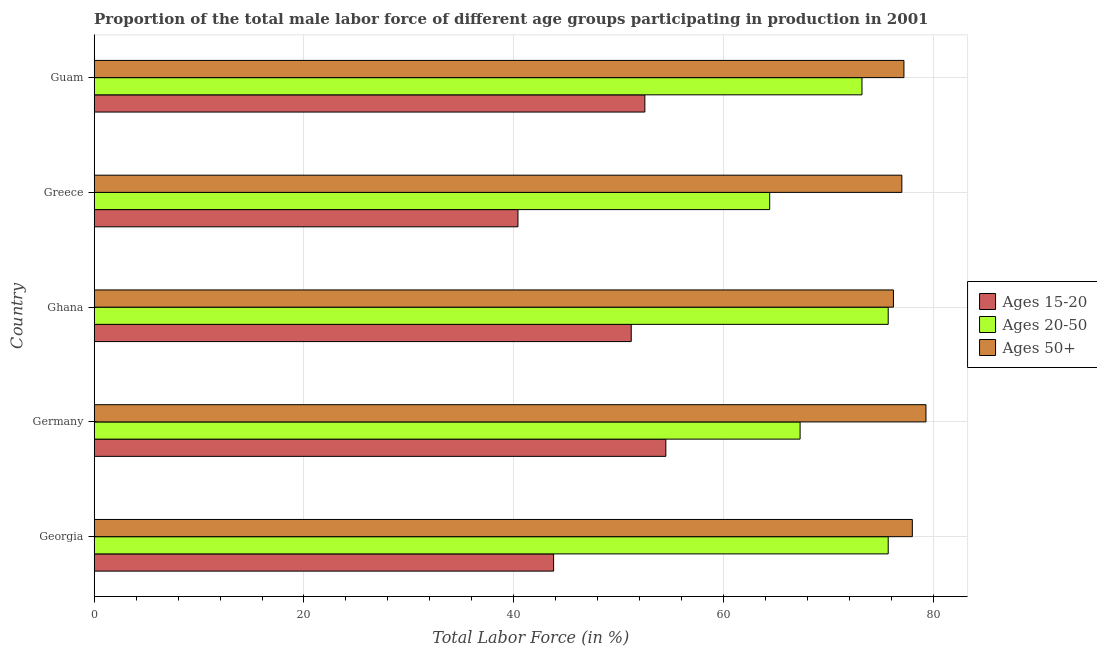How many groups of bars are there?
Ensure brevity in your answer.  5. Are the number of bars per tick equal to the number of legend labels?
Give a very brief answer. Yes. How many bars are there on the 2nd tick from the top?
Your response must be concise. 3. In how many cases, is the number of bars for a given country not equal to the number of legend labels?
Provide a succinct answer. 0. What is the percentage of male labor force above age 50 in Ghana?
Offer a very short reply. 76.2. Across all countries, what is the maximum percentage of male labor force within the age group 20-50?
Your answer should be very brief. 75.7. Across all countries, what is the minimum percentage of male labor force within the age group 15-20?
Offer a very short reply. 40.4. In which country was the percentage of male labor force within the age group 20-50 maximum?
Offer a terse response. Georgia. What is the total percentage of male labor force within the age group 20-50 in the graph?
Your answer should be very brief. 356.3. What is the difference between the percentage of male labor force within the age group 20-50 in Ghana and that in Guam?
Offer a very short reply. 2.5. What is the difference between the percentage of male labor force above age 50 in Ghana and the percentage of male labor force within the age group 20-50 in Greece?
Offer a very short reply. 11.8. What is the average percentage of male labor force within the age group 15-20 per country?
Your response must be concise. 48.48. What is the difference between the percentage of male labor force within the age group 15-20 and percentage of male labor force within the age group 20-50 in Ghana?
Give a very brief answer. -24.5. What is the ratio of the percentage of male labor force above age 50 in Ghana to that in Greece?
Your response must be concise. 0.99. Is the difference between the percentage of male labor force within the age group 20-50 in Germany and Guam greater than the difference between the percentage of male labor force within the age group 15-20 in Germany and Guam?
Give a very brief answer. No. What is the difference between the highest and the second highest percentage of male labor force within the age group 15-20?
Your answer should be compact. 2. What does the 3rd bar from the top in Ghana represents?
Your answer should be very brief. Ages 15-20. What does the 3rd bar from the bottom in Greece represents?
Offer a very short reply. Ages 50+. Is it the case that in every country, the sum of the percentage of male labor force within the age group 15-20 and percentage of male labor force within the age group 20-50 is greater than the percentage of male labor force above age 50?
Give a very brief answer. Yes. Are all the bars in the graph horizontal?
Your answer should be compact. Yes. What is the difference between two consecutive major ticks on the X-axis?
Ensure brevity in your answer.  20. Are the values on the major ticks of X-axis written in scientific E-notation?
Your answer should be very brief. No. Where does the legend appear in the graph?
Ensure brevity in your answer.  Center right. How many legend labels are there?
Your response must be concise. 3. How are the legend labels stacked?
Provide a succinct answer. Vertical. What is the title of the graph?
Give a very brief answer. Proportion of the total male labor force of different age groups participating in production in 2001. Does "Hydroelectric sources" appear as one of the legend labels in the graph?
Make the answer very short. No. What is the Total Labor Force (in %) in Ages 15-20 in Georgia?
Your answer should be very brief. 43.8. What is the Total Labor Force (in %) in Ages 20-50 in Georgia?
Your response must be concise. 75.7. What is the Total Labor Force (in %) of Ages 50+ in Georgia?
Your answer should be compact. 78. What is the Total Labor Force (in %) in Ages 15-20 in Germany?
Your answer should be compact. 54.5. What is the Total Labor Force (in %) in Ages 20-50 in Germany?
Provide a succinct answer. 67.3. What is the Total Labor Force (in %) in Ages 50+ in Germany?
Your answer should be compact. 79.3. What is the Total Labor Force (in %) of Ages 15-20 in Ghana?
Ensure brevity in your answer.  51.2. What is the Total Labor Force (in %) of Ages 20-50 in Ghana?
Offer a very short reply. 75.7. What is the Total Labor Force (in %) in Ages 50+ in Ghana?
Offer a terse response. 76.2. What is the Total Labor Force (in %) of Ages 15-20 in Greece?
Provide a short and direct response. 40.4. What is the Total Labor Force (in %) in Ages 20-50 in Greece?
Your answer should be very brief. 64.4. What is the Total Labor Force (in %) of Ages 50+ in Greece?
Make the answer very short. 77. What is the Total Labor Force (in %) of Ages 15-20 in Guam?
Offer a very short reply. 52.5. What is the Total Labor Force (in %) of Ages 20-50 in Guam?
Offer a terse response. 73.2. What is the Total Labor Force (in %) of Ages 50+ in Guam?
Make the answer very short. 77.2. Across all countries, what is the maximum Total Labor Force (in %) of Ages 15-20?
Provide a succinct answer. 54.5. Across all countries, what is the maximum Total Labor Force (in %) of Ages 20-50?
Ensure brevity in your answer.  75.7. Across all countries, what is the maximum Total Labor Force (in %) of Ages 50+?
Give a very brief answer. 79.3. Across all countries, what is the minimum Total Labor Force (in %) in Ages 15-20?
Provide a short and direct response. 40.4. Across all countries, what is the minimum Total Labor Force (in %) of Ages 20-50?
Ensure brevity in your answer.  64.4. Across all countries, what is the minimum Total Labor Force (in %) in Ages 50+?
Offer a terse response. 76.2. What is the total Total Labor Force (in %) in Ages 15-20 in the graph?
Your answer should be compact. 242.4. What is the total Total Labor Force (in %) in Ages 20-50 in the graph?
Your answer should be compact. 356.3. What is the total Total Labor Force (in %) in Ages 50+ in the graph?
Provide a short and direct response. 387.7. What is the difference between the Total Labor Force (in %) of Ages 20-50 in Georgia and that in Germany?
Provide a short and direct response. 8.4. What is the difference between the Total Labor Force (in %) of Ages 50+ in Georgia and that in Germany?
Your answer should be very brief. -1.3. What is the difference between the Total Labor Force (in %) of Ages 15-20 in Georgia and that in Ghana?
Offer a terse response. -7.4. What is the difference between the Total Labor Force (in %) in Ages 50+ in Georgia and that in Ghana?
Give a very brief answer. 1.8. What is the difference between the Total Labor Force (in %) of Ages 15-20 in Georgia and that in Greece?
Ensure brevity in your answer.  3.4. What is the difference between the Total Labor Force (in %) in Ages 20-50 in Georgia and that in Greece?
Provide a succinct answer. 11.3. What is the difference between the Total Labor Force (in %) in Ages 50+ in Georgia and that in Greece?
Keep it short and to the point. 1. What is the difference between the Total Labor Force (in %) in Ages 20-50 in Georgia and that in Guam?
Provide a short and direct response. 2.5. What is the difference between the Total Labor Force (in %) of Ages 20-50 in Germany and that in Ghana?
Your answer should be very brief. -8.4. What is the difference between the Total Labor Force (in %) of Ages 15-20 in Germany and that in Greece?
Your response must be concise. 14.1. What is the difference between the Total Labor Force (in %) of Ages 20-50 in Germany and that in Greece?
Your response must be concise. 2.9. What is the difference between the Total Labor Force (in %) in Ages 15-20 in Germany and that in Guam?
Provide a succinct answer. 2. What is the difference between the Total Labor Force (in %) of Ages 20-50 in Germany and that in Guam?
Keep it short and to the point. -5.9. What is the difference between the Total Labor Force (in %) in Ages 50+ in Germany and that in Guam?
Ensure brevity in your answer.  2.1. What is the difference between the Total Labor Force (in %) of Ages 20-50 in Ghana and that in Greece?
Provide a succinct answer. 11.3. What is the difference between the Total Labor Force (in %) of Ages 20-50 in Greece and that in Guam?
Give a very brief answer. -8.8. What is the difference between the Total Labor Force (in %) of Ages 15-20 in Georgia and the Total Labor Force (in %) of Ages 20-50 in Germany?
Offer a terse response. -23.5. What is the difference between the Total Labor Force (in %) in Ages 15-20 in Georgia and the Total Labor Force (in %) in Ages 50+ in Germany?
Make the answer very short. -35.5. What is the difference between the Total Labor Force (in %) of Ages 15-20 in Georgia and the Total Labor Force (in %) of Ages 20-50 in Ghana?
Give a very brief answer. -31.9. What is the difference between the Total Labor Force (in %) in Ages 15-20 in Georgia and the Total Labor Force (in %) in Ages 50+ in Ghana?
Give a very brief answer. -32.4. What is the difference between the Total Labor Force (in %) in Ages 15-20 in Georgia and the Total Labor Force (in %) in Ages 20-50 in Greece?
Make the answer very short. -20.6. What is the difference between the Total Labor Force (in %) of Ages 15-20 in Georgia and the Total Labor Force (in %) of Ages 50+ in Greece?
Make the answer very short. -33.2. What is the difference between the Total Labor Force (in %) of Ages 20-50 in Georgia and the Total Labor Force (in %) of Ages 50+ in Greece?
Offer a terse response. -1.3. What is the difference between the Total Labor Force (in %) in Ages 15-20 in Georgia and the Total Labor Force (in %) in Ages 20-50 in Guam?
Your answer should be very brief. -29.4. What is the difference between the Total Labor Force (in %) in Ages 15-20 in Georgia and the Total Labor Force (in %) in Ages 50+ in Guam?
Provide a succinct answer. -33.4. What is the difference between the Total Labor Force (in %) of Ages 15-20 in Germany and the Total Labor Force (in %) of Ages 20-50 in Ghana?
Ensure brevity in your answer.  -21.2. What is the difference between the Total Labor Force (in %) in Ages 15-20 in Germany and the Total Labor Force (in %) in Ages 50+ in Ghana?
Your response must be concise. -21.7. What is the difference between the Total Labor Force (in %) in Ages 20-50 in Germany and the Total Labor Force (in %) in Ages 50+ in Ghana?
Make the answer very short. -8.9. What is the difference between the Total Labor Force (in %) of Ages 15-20 in Germany and the Total Labor Force (in %) of Ages 20-50 in Greece?
Your answer should be compact. -9.9. What is the difference between the Total Labor Force (in %) in Ages 15-20 in Germany and the Total Labor Force (in %) in Ages 50+ in Greece?
Give a very brief answer. -22.5. What is the difference between the Total Labor Force (in %) of Ages 20-50 in Germany and the Total Labor Force (in %) of Ages 50+ in Greece?
Offer a very short reply. -9.7. What is the difference between the Total Labor Force (in %) of Ages 15-20 in Germany and the Total Labor Force (in %) of Ages 20-50 in Guam?
Your response must be concise. -18.7. What is the difference between the Total Labor Force (in %) in Ages 15-20 in Germany and the Total Labor Force (in %) in Ages 50+ in Guam?
Give a very brief answer. -22.7. What is the difference between the Total Labor Force (in %) of Ages 20-50 in Germany and the Total Labor Force (in %) of Ages 50+ in Guam?
Provide a succinct answer. -9.9. What is the difference between the Total Labor Force (in %) in Ages 15-20 in Ghana and the Total Labor Force (in %) in Ages 50+ in Greece?
Provide a short and direct response. -25.8. What is the difference between the Total Labor Force (in %) in Ages 20-50 in Ghana and the Total Labor Force (in %) in Ages 50+ in Greece?
Offer a terse response. -1.3. What is the difference between the Total Labor Force (in %) in Ages 15-20 in Ghana and the Total Labor Force (in %) in Ages 20-50 in Guam?
Provide a short and direct response. -22. What is the difference between the Total Labor Force (in %) in Ages 20-50 in Ghana and the Total Labor Force (in %) in Ages 50+ in Guam?
Give a very brief answer. -1.5. What is the difference between the Total Labor Force (in %) in Ages 15-20 in Greece and the Total Labor Force (in %) in Ages 20-50 in Guam?
Your answer should be very brief. -32.8. What is the difference between the Total Labor Force (in %) in Ages 15-20 in Greece and the Total Labor Force (in %) in Ages 50+ in Guam?
Provide a succinct answer. -36.8. What is the average Total Labor Force (in %) in Ages 15-20 per country?
Offer a very short reply. 48.48. What is the average Total Labor Force (in %) in Ages 20-50 per country?
Keep it short and to the point. 71.26. What is the average Total Labor Force (in %) of Ages 50+ per country?
Your response must be concise. 77.54. What is the difference between the Total Labor Force (in %) of Ages 15-20 and Total Labor Force (in %) of Ages 20-50 in Georgia?
Make the answer very short. -31.9. What is the difference between the Total Labor Force (in %) of Ages 15-20 and Total Labor Force (in %) of Ages 50+ in Georgia?
Your answer should be compact. -34.2. What is the difference between the Total Labor Force (in %) in Ages 20-50 and Total Labor Force (in %) in Ages 50+ in Georgia?
Ensure brevity in your answer.  -2.3. What is the difference between the Total Labor Force (in %) in Ages 15-20 and Total Labor Force (in %) in Ages 50+ in Germany?
Your answer should be very brief. -24.8. What is the difference between the Total Labor Force (in %) in Ages 20-50 and Total Labor Force (in %) in Ages 50+ in Germany?
Make the answer very short. -12. What is the difference between the Total Labor Force (in %) in Ages 15-20 and Total Labor Force (in %) in Ages 20-50 in Ghana?
Offer a very short reply. -24.5. What is the difference between the Total Labor Force (in %) of Ages 15-20 and Total Labor Force (in %) of Ages 50+ in Ghana?
Your answer should be compact. -25. What is the difference between the Total Labor Force (in %) in Ages 15-20 and Total Labor Force (in %) in Ages 20-50 in Greece?
Your answer should be very brief. -24. What is the difference between the Total Labor Force (in %) in Ages 15-20 and Total Labor Force (in %) in Ages 50+ in Greece?
Provide a short and direct response. -36.6. What is the difference between the Total Labor Force (in %) of Ages 15-20 and Total Labor Force (in %) of Ages 20-50 in Guam?
Give a very brief answer. -20.7. What is the difference between the Total Labor Force (in %) of Ages 15-20 and Total Labor Force (in %) of Ages 50+ in Guam?
Your answer should be very brief. -24.7. What is the difference between the Total Labor Force (in %) of Ages 20-50 and Total Labor Force (in %) of Ages 50+ in Guam?
Provide a succinct answer. -4. What is the ratio of the Total Labor Force (in %) of Ages 15-20 in Georgia to that in Germany?
Make the answer very short. 0.8. What is the ratio of the Total Labor Force (in %) in Ages 20-50 in Georgia to that in Germany?
Provide a succinct answer. 1.12. What is the ratio of the Total Labor Force (in %) of Ages 50+ in Georgia to that in Germany?
Your response must be concise. 0.98. What is the ratio of the Total Labor Force (in %) in Ages 15-20 in Georgia to that in Ghana?
Your response must be concise. 0.86. What is the ratio of the Total Labor Force (in %) of Ages 20-50 in Georgia to that in Ghana?
Make the answer very short. 1. What is the ratio of the Total Labor Force (in %) of Ages 50+ in Georgia to that in Ghana?
Provide a succinct answer. 1.02. What is the ratio of the Total Labor Force (in %) in Ages 15-20 in Georgia to that in Greece?
Provide a short and direct response. 1.08. What is the ratio of the Total Labor Force (in %) in Ages 20-50 in Georgia to that in Greece?
Your response must be concise. 1.18. What is the ratio of the Total Labor Force (in %) of Ages 50+ in Georgia to that in Greece?
Keep it short and to the point. 1.01. What is the ratio of the Total Labor Force (in %) in Ages 15-20 in Georgia to that in Guam?
Offer a very short reply. 0.83. What is the ratio of the Total Labor Force (in %) in Ages 20-50 in Georgia to that in Guam?
Give a very brief answer. 1.03. What is the ratio of the Total Labor Force (in %) in Ages 50+ in Georgia to that in Guam?
Your answer should be very brief. 1.01. What is the ratio of the Total Labor Force (in %) of Ages 15-20 in Germany to that in Ghana?
Keep it short and to the point. 1.06. What is the ratio of the Total Labor Force (in %) in Ages 20-50 in Germany to that in Ghana?
Your answer should be very brief. 0.89. What is the ratio of the Total Labor Force (in %) in Ages 50+ in Germany to that in Ghana?
Your response must be concise. 1.04. What is the ratio of the Total Labor Force (in %) of Ages 15-20 in Germany to that in Greece?
Offer a very short reply. 1.35. What is the ratio of the Total Labor Force (in %) of Ages 20-50 in Germany to that in Greece?
Provide a succinct answer. 1.04. What is the ratio of the Total Labor Force (in %) of Ages 50+ in Germany to that in Greece?
Provide a succinct answer. 1.03. What is the ratio of the Total Labor Force (in %) in Ages 15-20 in Germany to that in Guam?
Provide a succinct answer. 1.04. What is the ratio of the Total Labor Force (in %) of Ages 20-50 in Germany to that in Guam?
Your answer should be very brief. 0.92. What is the ratio of the Total Labor Force (in %) in Ages 50+ in Germany to that in Guam?
Offer a very short reply. 1.03. What is the ratio of the Total Labor Force (in %) in Ages 15-20 in Ghana to that in Greece?
Keep it short and to the point. 1.27. What is the ratio of the Total Labor Force (in %) of Ages 20-50 in Ghana to that in Greece?
Offer a terse response. 1.18. What is the ratio of the Total Labor Force (in %) in Ages 50+ in Ghana to that in Greece?
Provide a short and direct response. 0.99. What is the ratio of the Total Labor Force (in %) in Ages 15-20 in Ghana to that in Guam?
Keep it short and to the point. 0.98. What is the ratio of the Total Labor Force (in %) of Ages 20-50 in Ghana to that in Guam?
Provide a short and direct response. 1.03. What is the ratio of the Total Labor Force (in %) of Ages 50+ in Ghana to that in Guam?
Your answer should be very brief. 0.99. What is the ratio of the Total Labor Force (in %) in Ages 15-20 in Greece to that in Guam?
Your response must be concise. 0.77. What is the ratio of the Total Labor Force (in %) of Ages 20-50 in Greece to that in Guam?
Ensure brevity in your answer.  0.88. What is the difference between the highest and the lowest Total Labor Force (in %) in Ages 15-20?
Your answer should be compact. 14.1. What is the difference between the highest and the lowest Total Labor Force (in %) in Ages 20-50?
Give a very brief answer. 11.3. What is the difference between the highest and the lowest Total Labor Force (in %) in Ages 50+?
Your response must be concise. 3.1. 